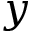Convert formula to latex. <formula><loc_0><loc_0><loc_500><loc_500>y</formula> 